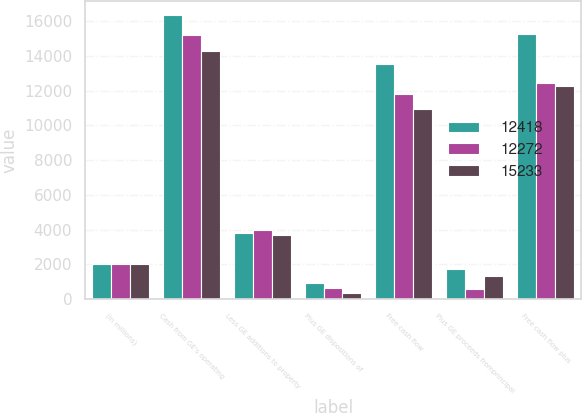Convert chart. <chart><loc_0><loc_0><loc_500><loc_500><stacked_bar_chart><ecel><fcel>(In millions)<fcel>Cash from GE's operating<fcel>Less GE additions to property<fcel>Plus GE dispositions of<fcel>Free cash flow<fcel>Plus GE proceeds fromprincipal<fcel>Free cash flow plus<nl><fcel>12418<fcel>2015<fcel>16354<fcel>3785<fcel>939<fcel>13508<fcel>1725<fcel>15233<nl><fcel>12272<fcel>2014<fcel>15171<fcel>3970<fcel>615<fcel>11816<fcel>602<fcel>12418<nl><fcel>15233<fcel>2013<fcel>14255<fcel>3680<fcel>381<fcel>10956<fcel>1316<fcel>12272<nl></chart> 